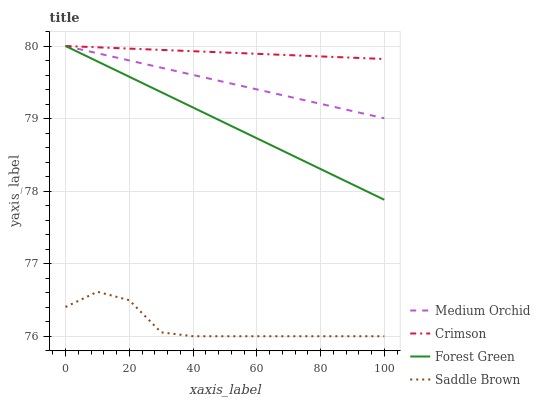Does Saddle Brown have the minimum area under the curve?
Answer yes or no. Yes. Does Crimson have the maximum area under the curve?
Answer yes or no. Yes. Does Forest Green have the minimum area under the curve?
Answer yes or no. No. Does Forest Green have the maximum area under the curve?
Answer yes or no. No. Is Forest Green the smoothest?
Answer yes or no. Yes. Is Saddle Brown the roughest?
Answer yes or no. Yes. Is Medium Orchid the smoothest?
Answer yes or no. No. Is Medium Orchid the roughest?
Answer yes or no. No. Does Saddle Brown have the lowest value?
Answer yes or no. Yes. Does Forest Green have the lowest value?
Answer yes or no. No. Does Medium Orchid have the highest value?
Answer yes or no. Yes. Does Saddle Brown have the highest value?
Answer yes or no. No. Is Saddle Brown less than Crimson?
Answer yes or no. Yes. Is Forest Green greater than Saddle Brown?
Answer yes or no. Yes. Does Medium Orchid intersect Crimson?
Answer yes or no. Yes. Is Medium Orchid less than Crimson?
Answer yes or no. No. Is Medium Orchid greater than Crimson?
Answer yes or no. No. Does Saddle Brown intersect Crimson?
Answer yes or no. No. 